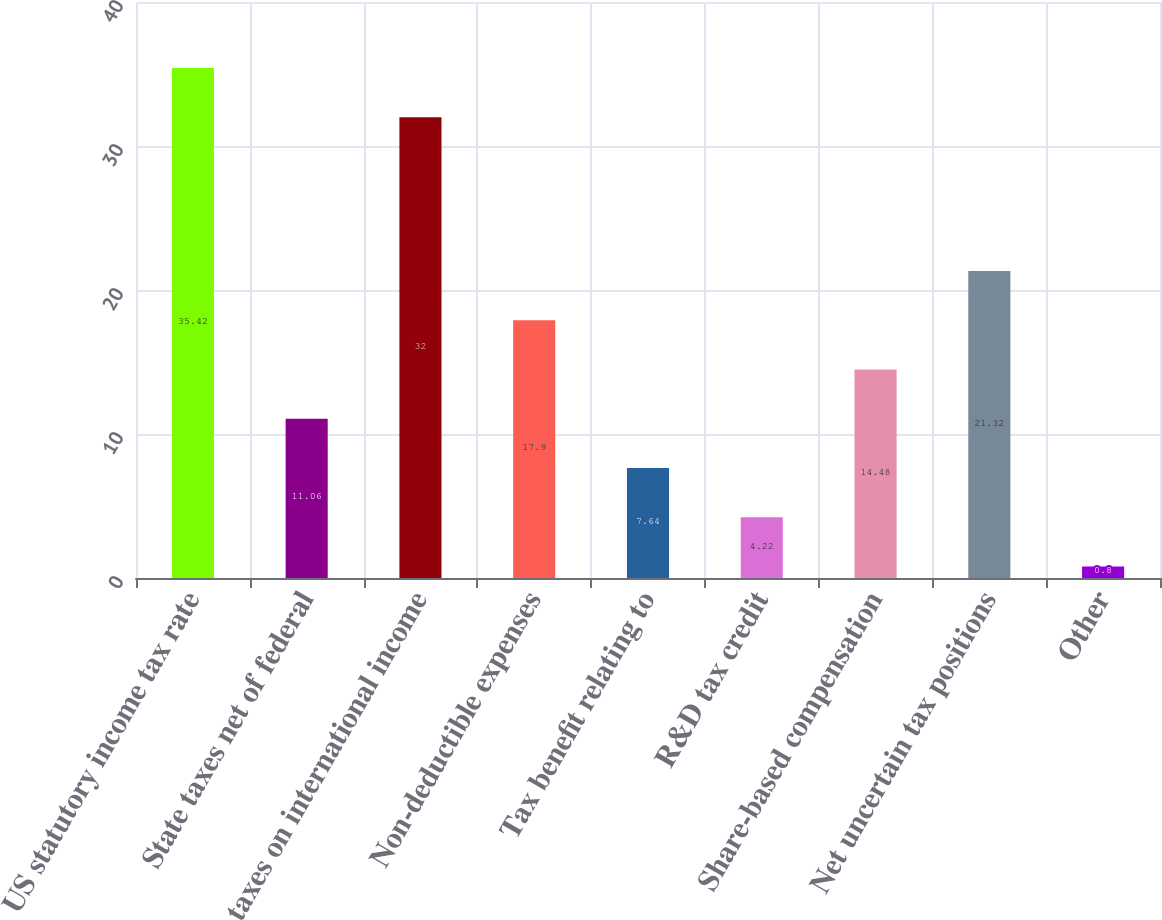<chart> <loc_0><loc_0><loc_500><loc_500><bar_chart><fcel>US statutory income tax rate<fcel>State taxes net of federal<fcel>taxes on international income<fcel>Non-deductible expenses<fcel>Tax benefit relating to<fcel>R&D tax credit<fcel>Share-based compensation<fcel>Net uncertain tax positions<fcel>Other<nl><fcel>35.42<fcel>11.06<fcel>32<fcel>17.9<fcel>7.64<fcel>4.22<fcel>14.48<fcel>21.32<fcel>0.8<nl></chart> 